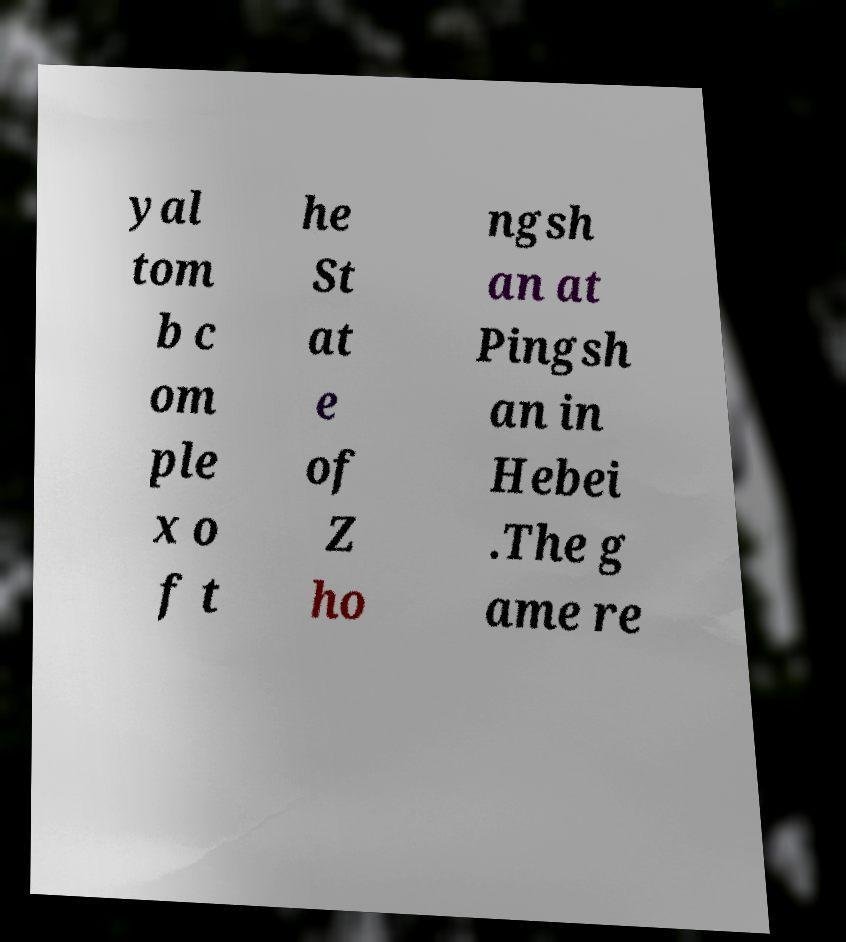I need the written content from this picture converted into text. Can you do that? yal tom b c om ple x o f t he St at e of Z ho ngsh an at Pingsh an in Hebei .The g ame re 